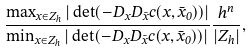Convert formula to latex. <formula><loc_0><loc_0><loc_500><loc_500>\frac { \max _ { x \in Z _ { h } } | \det ( - D _ { x } D _ { \bar { x } } c ( x , \bar { x } _ { 0 } ) ) | } { \min _ { x \in Z _ { h } } | \det ( - D _ { x } D _ { \bar { x } } c ( x , \bar { x } _ { 0 } ) ) | } \frac { h ^ { n } } { | Z _ { h } | } ,</formula> 